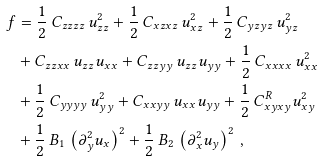Convert formula to latex. <formula><loc_0><loc_0><loc_500><loc_500>f & = \frac { 1 } { 2 } \, C _ { z z z z } \, u _ { z z } ^ { 2 } + \frac { 1 } { 2 } \, C _ { x z x z } \, u _ { x z } ^ { 2 } + \frac { 1 } { 2 } \, C _ { y z y z } \, u _ { y z } ^ { 2 } \\ & + C _ { z z x x } \, u _ { z z } u _ { x x } + C _ { z z y y } \, u _ { z z } u _ { y y } + \frac { 1 } { 2 } \, C _ { x x x x } \, u _ { x x } ^ { 2 } \\ & + \frac { 1 } { 2 } \, C _ { y y y y } \, u _ { y y } ^ { 2 } + C _ { x x y y } \, u _ { x x } u _ { y y } + \frac { 1 } { 2 } \, C _ { x y x y } ^ { R } u _ { x y } ^ { 2 } \\ & + \frac { 1 } { 2 } \, B _ { 1 } \, \left ( \partial _ { y } ^ { 2 } u _ { x } \right ) ^ { 2 } + \frac { 1 } { 2 } \, B _ { 2 } \, \left ( \partial _ { x } ^ { 2 } u _ { y } \right ) ^ { 2 } \, ,</formula> 